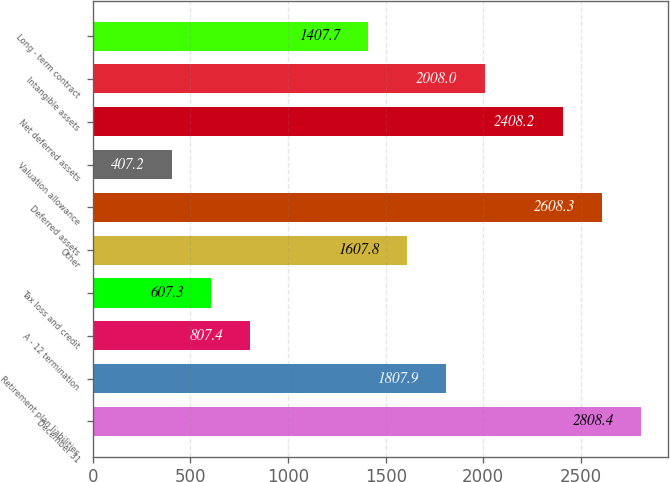<chart> <loc_0><loc_0><loc_500><loc_500><bar_chart><fcel>December 31<fcel>Retirement plan liabilities<fcel>A - 12 termination<fcel>Tax loss and credit<fcel>Other<fcel>Deferred assets<fcel>Valuation allowance<fcel>Net deferred assets<fcel>Intangible assets<fcel>Long - term contract<nl><fcel>2808.4<fcel>1807.9<fcel>807.4<fcel>607.3<fcel>1607.8<fcel>2608.3<fcel>407.2<fcel>2408.2<fcel>2008<fcel>1407.7<nl></chart> 